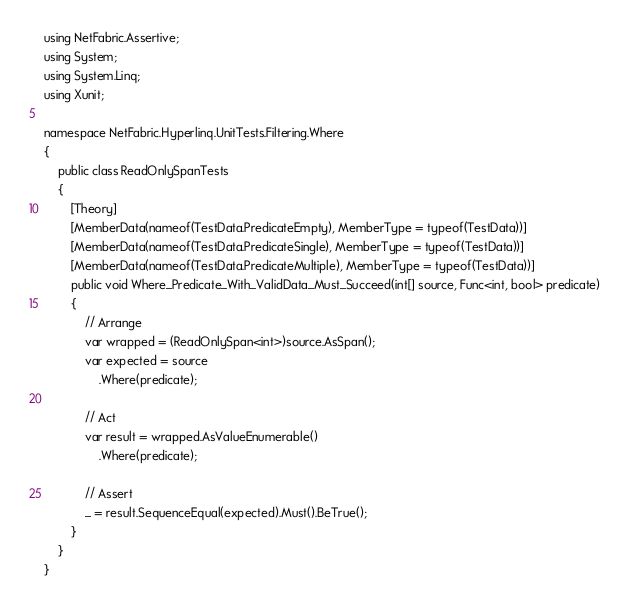<code> <loc_0><loc_0><loc_500><loc_500><_C#_>using NetFabric.Assertive;
using System;
using System.Linq;
using Xunit;

namespace NetFabric.Hyperlinq.UnitTests.Filtering.Where
{
    public class ReadOnlySpanTests
    {
        [Theory]
        [MemberData(nameof(TestData.PredicateEmpty), MemberType = typeof(TestData))]
        [MemberData(nameof(TestData.PredicateSingle), MemberType = typeof(TestData))]
        [MemberData(nameof(TestData.PredicateMultiple), MemberType = typeof(TestData))]
        public void Where_Predicate_With_ValidData_Must_Succeed(int[] source, Func<int, bool> predicate)
        {
            // Arrange
            var wrapped = (ReadOnlySpan<int>)source.AsSpan();
            var expected = source
                .Where(predicate);

            // Act
            var result = wrapped.AsValueEnumerable()
                .Where(predicate);

            // Assert
            _ = result.SequenceEqual(expected).Must().BeTrue();
        }
    }
}</code> 